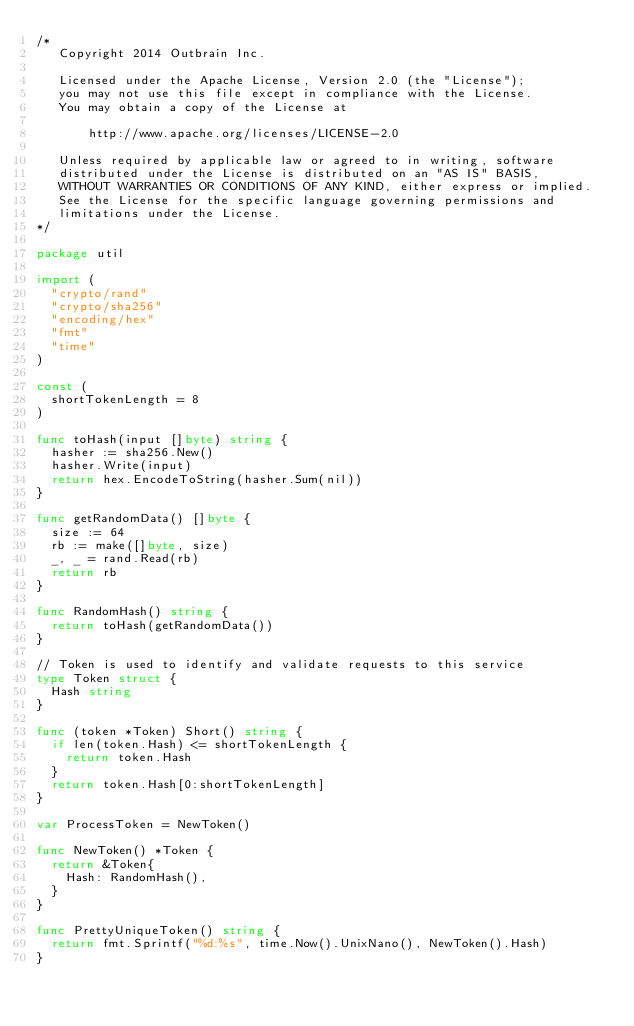Convert code to text. <code><loc_0><loc_0><loc_500><loc_500><_Go_>/*
   Copyright 2014 Outbrain Inc.

   Licensed under the Apache License, Version 2.0 (the "License");
   you may not use this file except in compliance with the License.
   You may obtain a copy of the License at

       http://www.apache.org/licenses/LICENSE-2.0

   Unless required by applicable law or agreed to in writing, software
   distributed under the License is distributed on an "AS IS" BASIS,
   WITHOUT WARRANTIES OR CONDITIONS OF ANY KIND, either express or implied.
   See the License for the specific language governing permissions and
   limitations under the License.
*/

package util

import (
	"crypto/rand"
	"crypto/sha256"
	"encoding/hex"
	"fmt"
	"time"
)

const (
	shortTokenLength = 8
)

func toHash(input []byte) string {
	hasher := sha256.New()
	hasher.Write(input)
	return hex.EncodeToString(hasher.Sum(nil))
}

func getRandomData() []byte {
	size := 64
	rb := make([]byte, size)
	_, _ = rand.Read(rb)
	return rb
}

func RandomHash() string {
	return toHash(getRandomData())
}

// Token is used to identify and validate requests to this service
type Token struct {
	Hash string
}

func (token *Token) Short() string {
	if len(token.Hash) <= shortTokenLength {
		return token.Hash
	}
	return token.Hash[0:shortTokenLength]
}

var ProcessToken = NewToken()

func NewToken() *Token {
	return &Token{
		Hash: RandomHash(),
	}
}

func PrettyUniqueToken() string {
	return fmt.Sprintf("%d:%s", time.Now().UnixNano(), NewToken().Hash)
}
</code> 